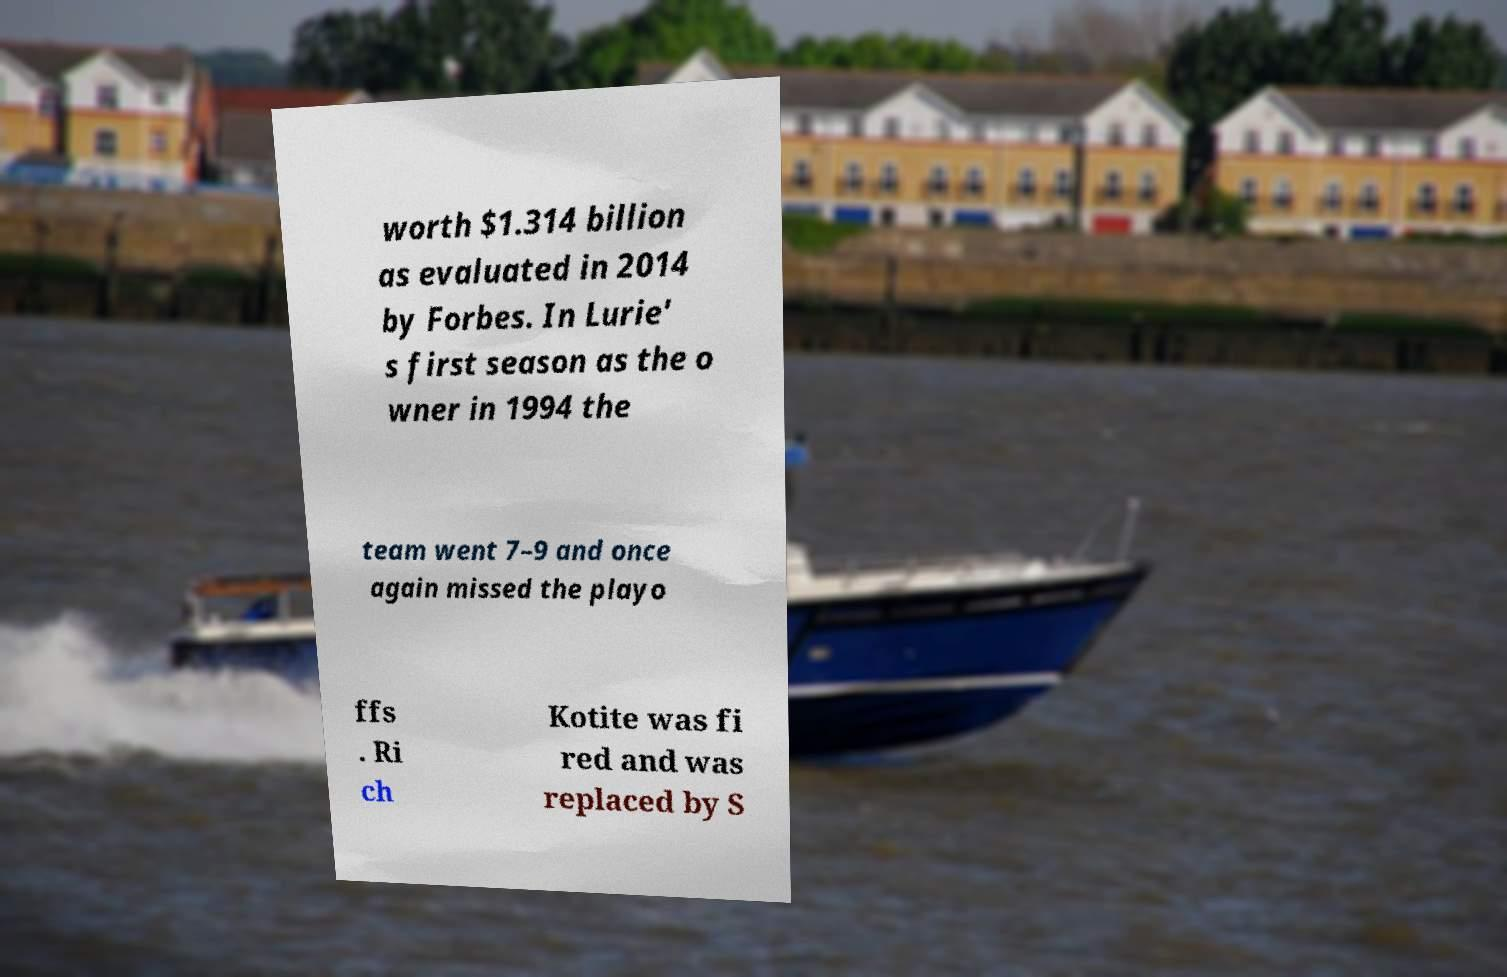What messages or text are displayed in this image? I need them in a readable, typed format. worth $1.314 billion as evaluated in 2014 by Forbes. In Lurie' s first season as the o wner in 1994 the team went 7–9 and once again missed the playo ffs . Ri ch Kotite was fi red and was replaced by S 